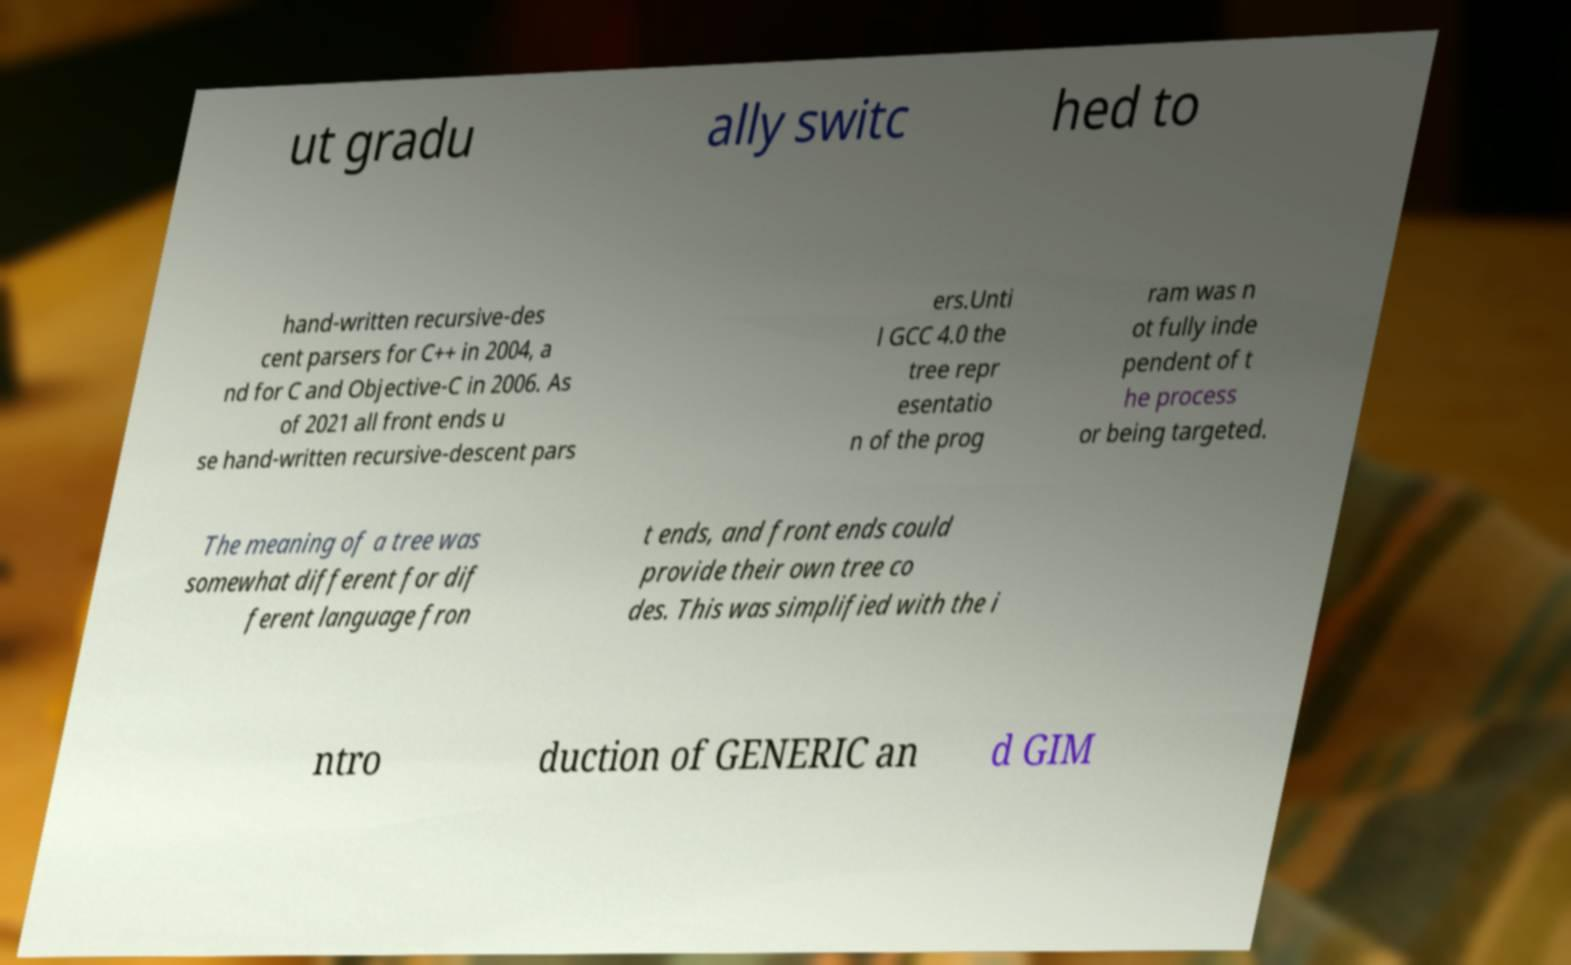For documentation purposes, I need the text within this image transcribed. Could you provide that? ut gradu ally switc hed to hand-written recursive-des cent parsers for C++ in 2004, a nd for C and Objective-C in 2006. As of 2021 all front ends u se hand-written recursive-descent pars ers.Unti l GCC 4.0 the tree repr esentatio n of the prog ram was n ot fully inde pendent of t he process or being targeted. The meaning of a tree was somewhat different for dif ferent language fron t ends, and front ends could provide their own tree co des. This was simplified with the i ntro duction of GENERIC an d GIM 